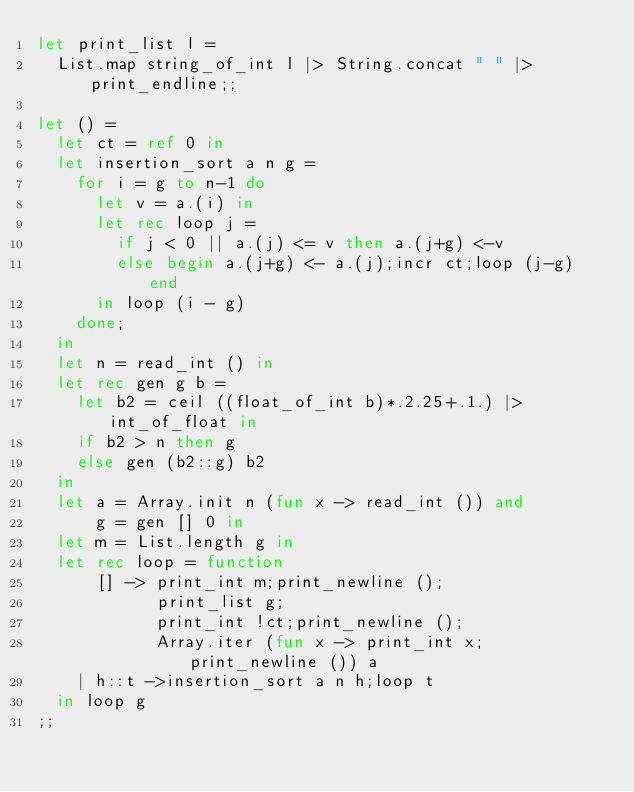Convert code to text. <code><loc_0><loc_0><loc_500><loc_500><_OCaml_>let print_list l =
  List.map string_of_int l |> String.concat " " |> print_endline;;

let () =
  let ct = ref 0 in
  let insertion_sort a n g =
    for i = g to n-1 do
      let v = a.(i) in
      let rec loop j =
        if j < 0 || a.(j) <= v then a.(j+g) <-v
        else begin a.(j+g) <- a.(j);incr ct;loop (j-g) end
      in loop (i - g)
    done;
  in
  let n = read_int () in
  let rec gen g b =
    let b2 = ceil ((float_of_int b)*.2.25+.1.) |> int_of_float in
    if b2 > n then g
    else gen (b2::g) b2
  in
  let a = Array.init n (fun x -> read_int ()) and
      g = gen [] 0 in
  let m = List.length g in
  let rec loop = function
      [] -> print_int m;print_newline ();
            print_list g;
            print_int !ct;print_newline ();
            Array.iter (fun x -> print_int x;print_newline ()) a
    | h::t ->insertion_sort a n h;loop t
  in loop g
;;</code> 